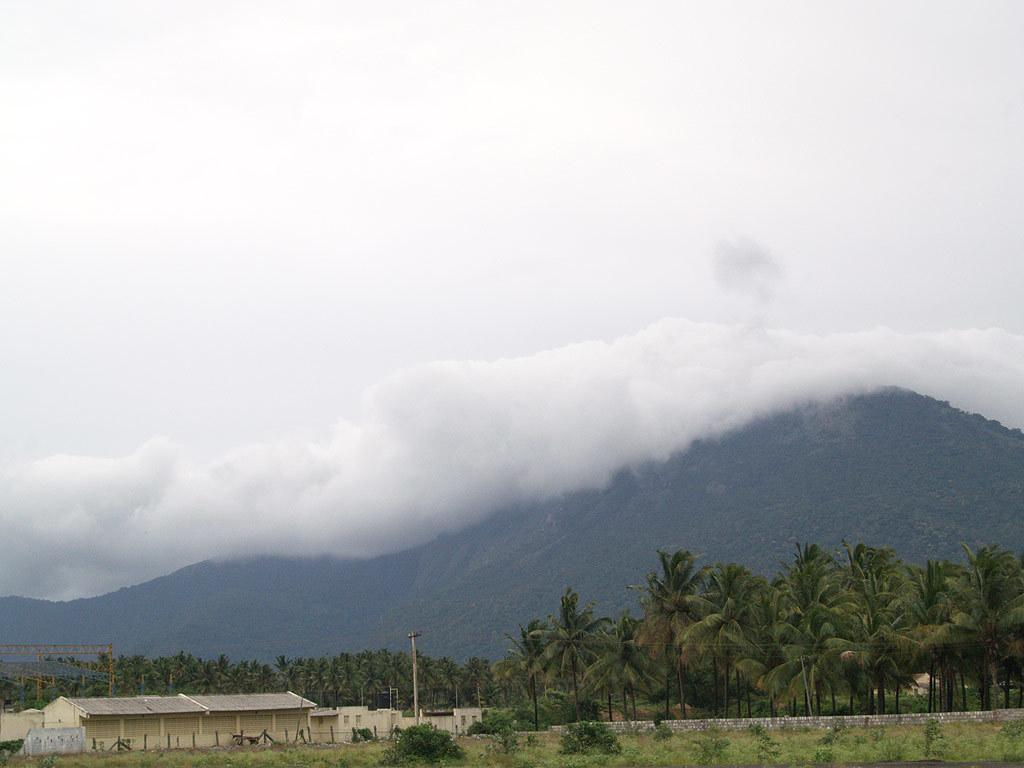What type of vegetation can be seen in the image? There are trees in the image. What structure is present in the image? There is a pole in the image. What type of buildings are visible at the bottom of the image? Houses are visible at the bottom of the image. What other type of vegetation is present at the bottom of the image? Plants are present at the bottom of the image. What natural features can be seen in the distance? There are mountains in the image. What is visible in the sky? Clouds are visible in the sky. What type of loaf is being used to draw on the pole in the image? There is no loaf present in the image, and the pole is not being used for drawing. Can you tell me how many pencils are lying on the ground near the plants? There is no mention of pencils in the image, so it cannot be determined how many are present. 